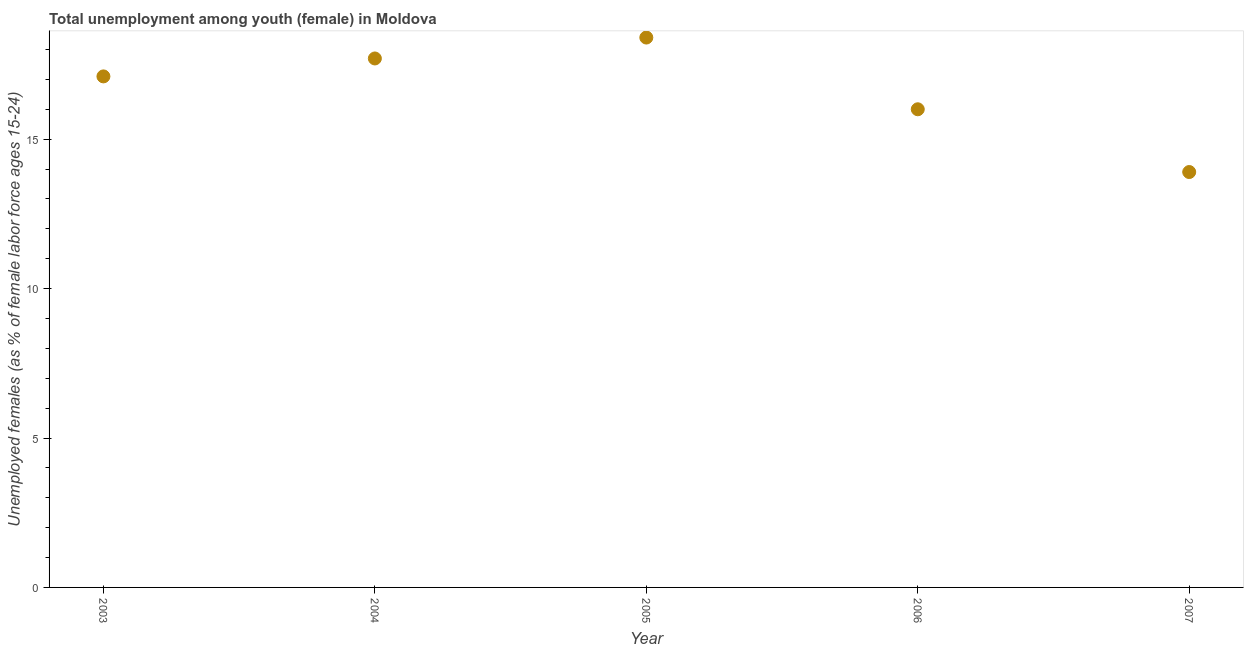What is the unemployed female youth population in 2004?
Your response must be concise. 17.7. Across all years, what is the maximum unemployed female youth population?
Provide a succinct answer. 18.4. Across all years, what is the minimum unemployed female youth population?
Provide a succinct answer. 13.9. In which year was the unemployed female youth population minimum?
Provide a short and direct response. 2007. What is the sum of the unemployed female youth population?
Offer a very short reply. 83.1. What is the difference between the unemployed female youth population in 2006 and 2007?
Your response must be concise. 2.1. What is the average unemployed female youth population per year?
Provide a succinct answer. 16.62. What is the median unemployed female youth population?
Your answer should be very brief. 17.1. In how many years, is the unemployed female youth population greater than 10 %?
Give a very brief answer. 5. What is the ratio of the unemployed female youth population in 2004 to that in 2005?
Keep it short and to the point. 0.96. Is the unemployed female youth population in 2003 less than that in 2007?
Give a very brief answer. No. Is the difference between the unemployed female youth population in 2006 and 2007 greater than the difference between any two years?
Your response must be concise. No. What is the difference between the highest and the second highest unemployed female youth population?
Give a very brief answer. 0.7. What is the difference between the highest and the lowest unemployed female youth population?
Offer a terse response. 4.5. Does the unemployed female youth population monotonically increase over the years?
Keep it short and to the point. No. Does the graph contain any zero values?
Make the answer very short. No. What is the title of the graph?
Keep it short and to the point. Total unemployment among youth (female) in Moldova. What is the label or title of the Y-axis?
Ensure brevity in your answer.  Unemployed females (as % of female labor force ages 15-24). What is the Unemployed females (as % of female labor force ages 15-24) in 2003?
Offer a very short reply. 17.1. What is the Unemployed females (as % of female labor force ages 15-24) in 2004?
Your answer should be very brief. 17.7. What is the Unemployed females (as % of female labor force ages 15-24) in 2005?
Make the answer very short. 18.4. What is the Unemployed females (as % of female labor force ages 15-24) in 2007?
Make the answer very short. 13.9. What is the difference between the Unemployed females (as % of female labor force ages 15-24) in 2003 and 2005?
Provide a succinct answer. -1.3. What is the difference between the Unemployed females (as % of female labor force ages 15-24) in 2003 and 2006?
Your response must be concise. 1.1. What is the difference between the Unemployed females (as % of female labor force ages 15-24) in 2003 and 2007?
Give a very brief answer. 3.2. What is the difference between the Unemployed females (as % of female labor force ages 15-24) in 2004 and 2007?
Make the answer very short. 3.8. What is the difference between the Unemployed females (as % of female labor force ages 15-24) in 2005 and 2006?
Make the answer very short. 2.4. What is the ratio of the Unemployed females (as % of female labor force ages 15-24) in 2003 to that in 2004?
Ensure brevity in your answer.  0.97. What is the ratio of the Unemployed females (as % of female labor force ages 15-24) in 2003 to that in 2005?
Your answer should be very brief. 0.93. What is the ratio of the Unemployed females (as % of female labor force ages 15-24) in 2003 to that in 2006?
Make the answer very short. 1.07. What is the ratio of the Unemployed females (as % of female labor force ages 15-24) in 2003 to that in 2007?
Provide a short and direct response. 1.23. What is the ratio of the Unemployed females (as % of female labor force ages 15-24) in 2004 to that in 2006?
Provide a short and direct response. 1.11. What is the ratio of the Unemployed females (as % of female labor force ages 15-24) in 2004 to that in 2007?
Make the answer very short. 1.27. What is the ratio of the Unemployed females (as % of female labor force ages 15-24) in 2005 to that in 2006?
Keep it short and to the point. 1.15. What is the ratio of the Unemployed females (as % of female labor force ages 15-24) in 2005 to that in 2007?
Ensure brevity in your answer.  1.32. What is the ratio of the Unemployed females (as % of female labor force ages 15-24) in 2006 to that in 2007?
Make the answer very short. 1.15. 